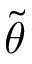Convert formula to latex. <formula><loc_0><loc_0><loc_500><loc_500>\tilde { \theta }</formula> 